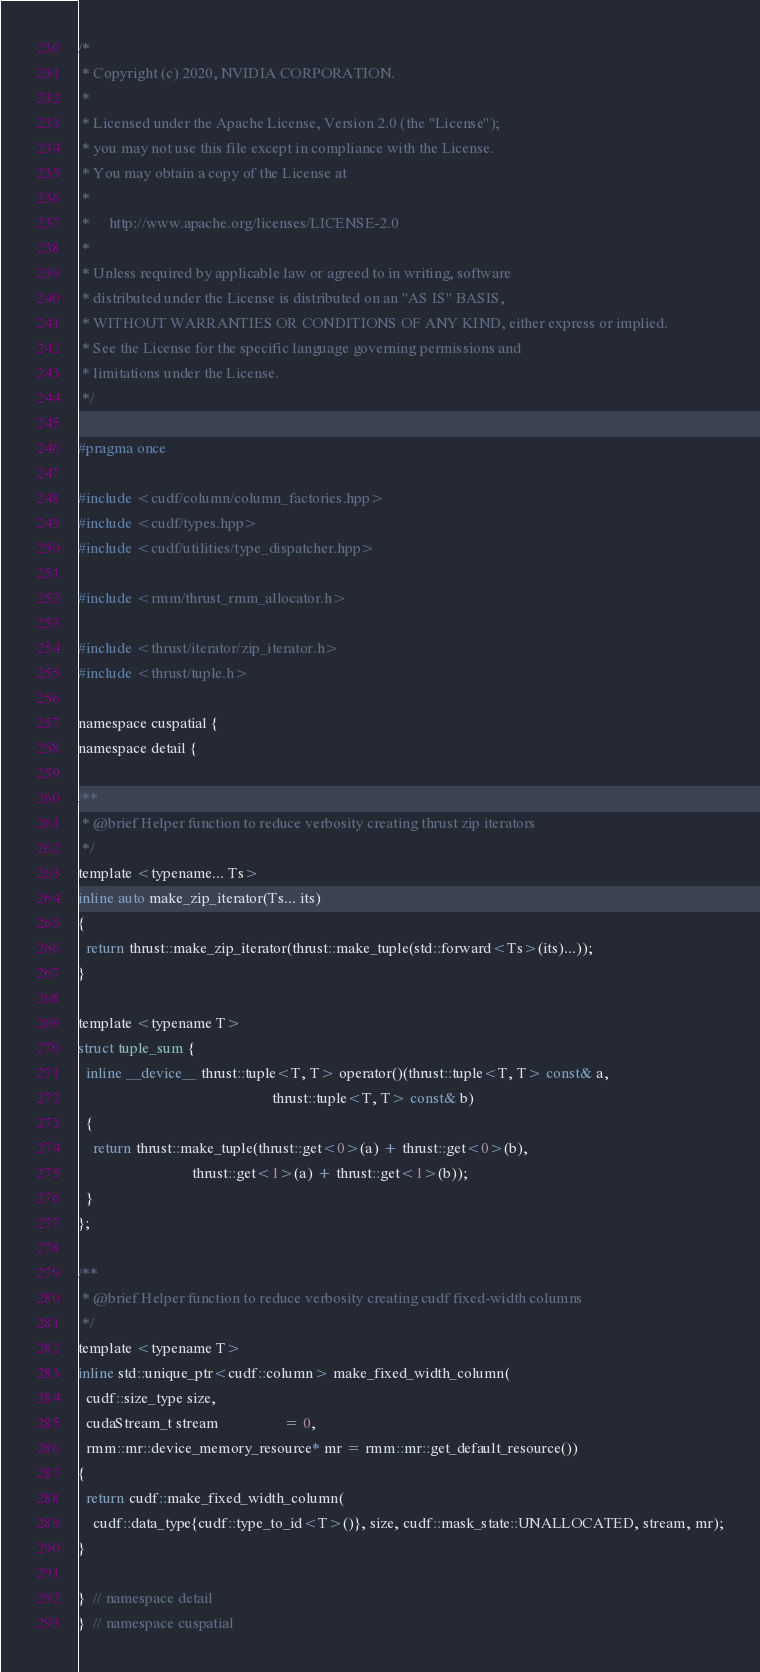<code> <loc_0><loc_0><loc_500><loc_500><_Cuda_>/*
 * Copyright (c) 2020, NVIDIA CORPORATION.
 *
 * Licensed under the Apache License, Version 2.0 (the "License");
 * you may not use this file except in compliance with the License.
 * You may obtain a copy of the License at
 *
 *     http://www.apache.org/licenses/LICENSE-2.0
 *
 * Unless required by applicable law or agreed to in writing, software
 * distributed under the License is distributed on an "AS IS" BASIS,
 * WITHOUT WARRANTIES OR CONDITIONS OF ANY KIND, either express or implied.
 * See the License for the specific language governing permissions and
 * limitations under the License.
 */

#pragma once

#include <cudf/column/column_factories.hpp>
#include <cudf/types.hpp>
#include <cudf/utilities/type_dispatcher.hpp>

#include <rmm/thrust_rmm_allocator.h>

#include <thrust/iterator/zip_iterator.h>
#include <thrust/tuple.h>

namespace cuspatial {
namespace detail {

/**
 * @brief Helper function to reduce verbosity creating thrust zip iterators
 */
template <typename... Ts>
inline auto make_zip_iterator(Ts... its)
{
  return thrust::make_zip_iterator(thrust::make_tuple(std::forward<Ts>(its)...));
}

template <typename T>
struct tuple_sum {
  inline __device__ thrust::tuple<T, T> operator()(thrust::tuple<T, T> const& a,
                                                   thrust::tuple<T, T> const& b)
  {
    return thrust::make_tuple(thrust::get<0>(a) + thrust::get<0>(b),
                              thrust::get<1>(a) + thrust::get<1>(b));
  }
};

/**
 * @brief Helper function to reduce verbosity creating cudf fixed-width columns
 */
template <typename T>
inline std::unique_ptr<cudf::column> make_fixed_width_column(
  cudf::size_type size,
  cudaStream_t stream                 = 0,
  rmm::mr::device_memory_resource* mr = rmm::mr::get_default_resource())
{
  return cudf::make_fixed_width_column(
    cudf::data_type{cudf::type_to_id<T>()}, size, cudf::mask_state::UNALLOCATED, stream, mr);
}

}  // namespace detail
}  // namespace cuspatial
</code> 